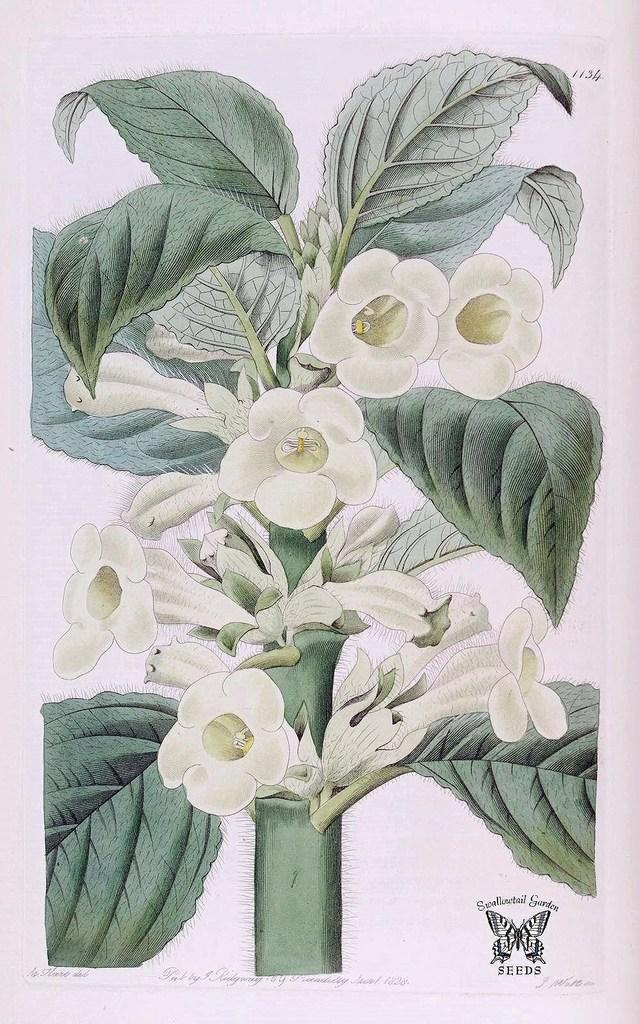What type of artwork is depicted in the image? The image is a painting. What is the main subject of the painting? There is a plant in the center of the painting. Are there any other elements in the painting besides the plant? Yes, there are flowers in the painting. What type of club can be seen in the painting? There is no club present in the painting; it features a plant and flowers. What is the angle of the slope in the painting? There is no slope present in the painting; it features a plant and flowers. 